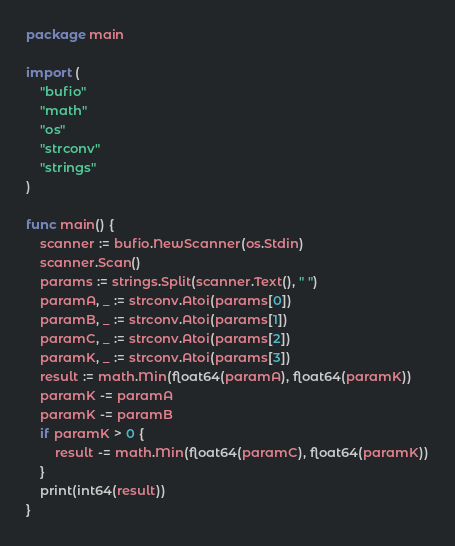<code> <loc_0><loc_0><loc_500><loc_500><_Go_>package main

import (
	"bufio"
	"math"
	"os"
	"strconv"
	"strings"
)

func main() {
	scanner := bufio.NewScanner(os.Stdin)
	scanner.Scan()
	params := strings.Split(scanner.Text(), " ")
	paramA, _ := strconv.Atoi(params[0])
	paramB, _ := strconv.Atoi(params[1])
	paramC, _ := strconv.Atoi(params[2])
	paramK, _ := strconv.Atoi(params[3])
	result := math.Min(float64(paramA), float64(paramK))
	paramK -= paramA
	paramK -= paramB
	if paramK > 0 {
		result -= math.Min(float64(paramC), float64(paramK))
	}
	print(int64(result))
}
</code> 